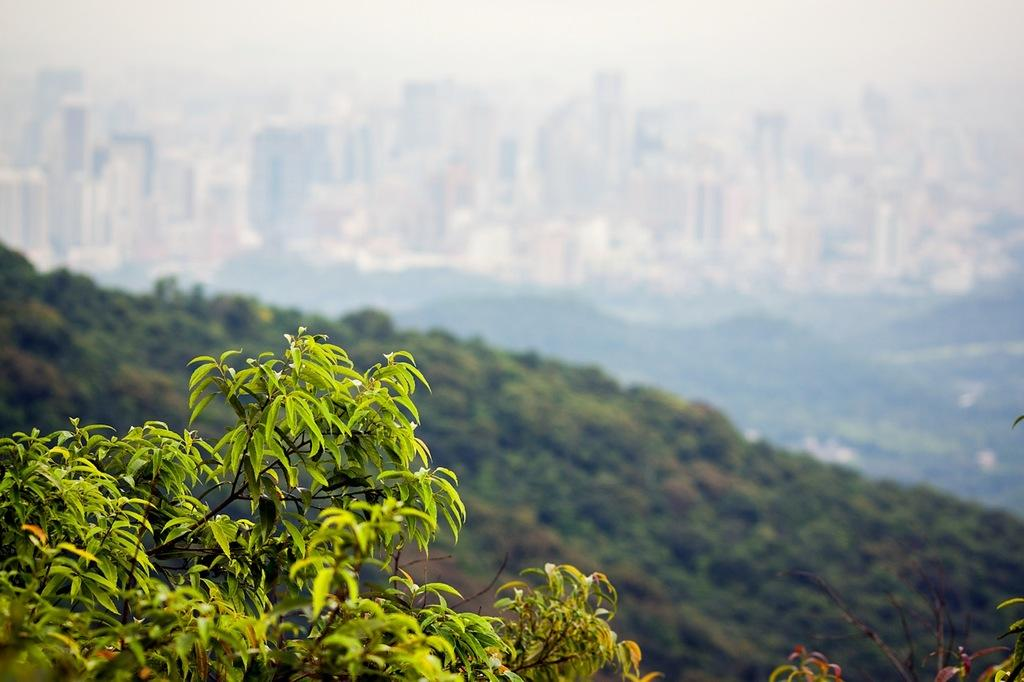What type of natural element is present in the image? There is a tree in the image. What can be seen in the distance in the image? There are hills and buildings in the background of the image. Can you see any caves in the image? There are no caves visible in the image; it features a tree, hills, and buildings. 